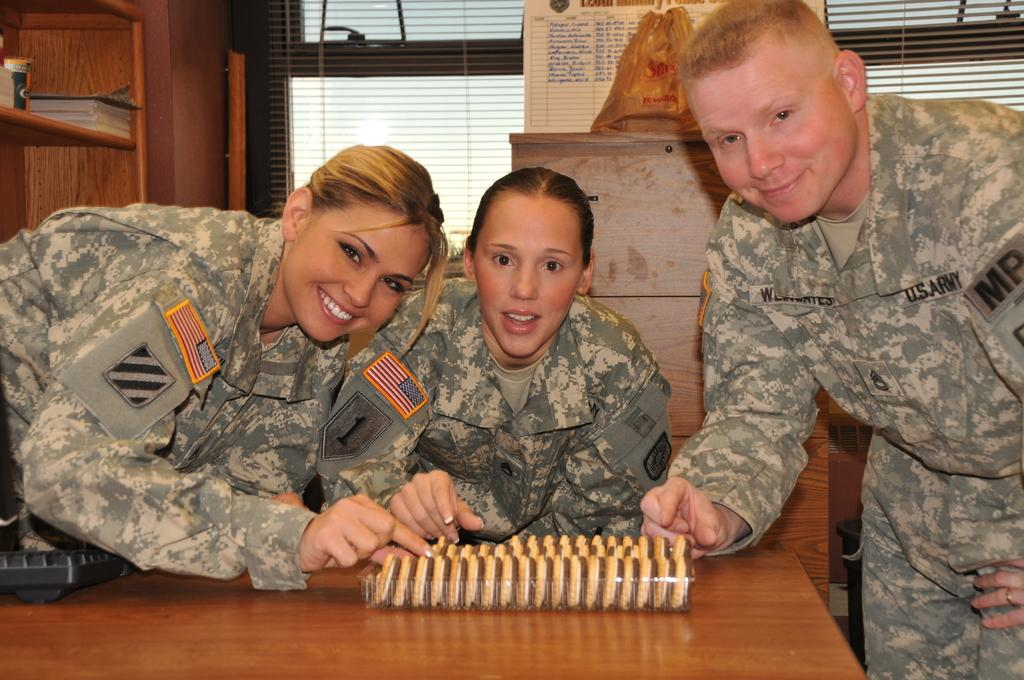What type of structure can be seen in the image? There is a wall in the image. What is covering the windows in the image? Window blinds are present in the image. What are the three persons in the image wearing? They are wearing army dresses in the image. What piece of furniture is in the image? There is a table in the image. What object is on the table? A keyboard is on the table. What type of box can be seen in the image? There is no box present in the image. What is the desire of the persons in the image? The image does not provide information about the desires of the persons in the image. 